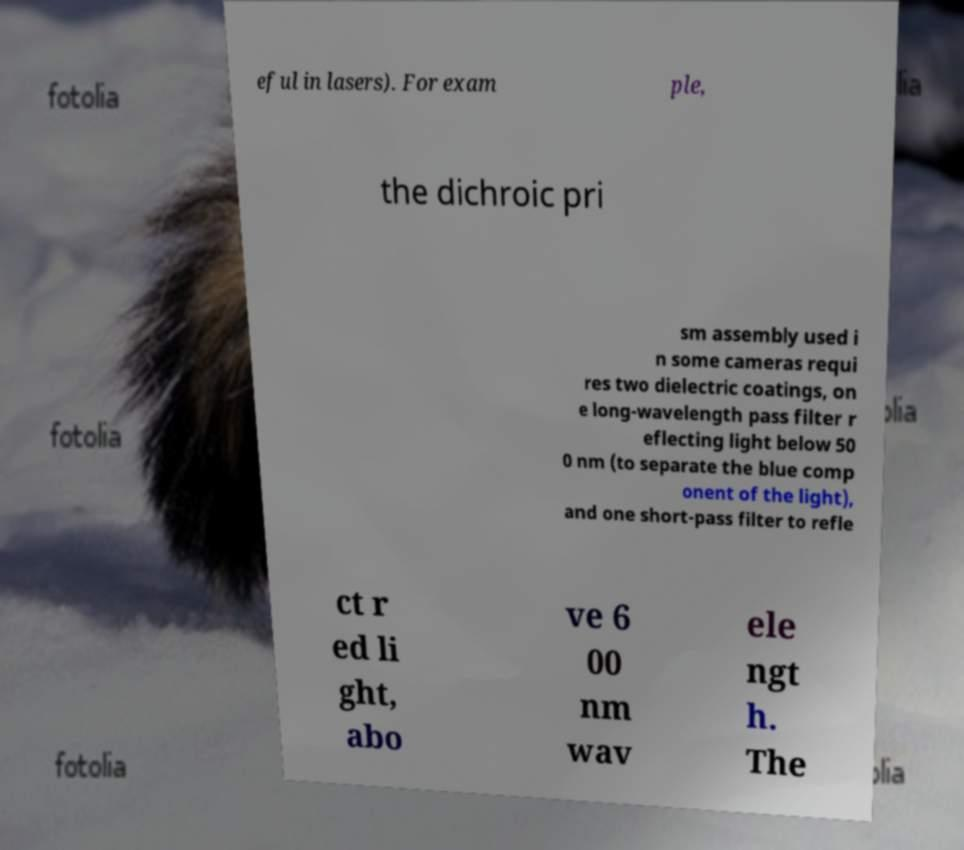I need the written content from this picture converted into text. Can you do that? eful in lasers). For exam ple, the dichroic pri sm assembly used i n some cameras requi res two dielectric coatings, on e long-wavelength pass filter r eflecting light below 50 0 nm (to separate the blue comp onent of the light), and one short-pass filter to refle ct r ed li ght, abo ve 6 00 nm wav ele ngt h. The 